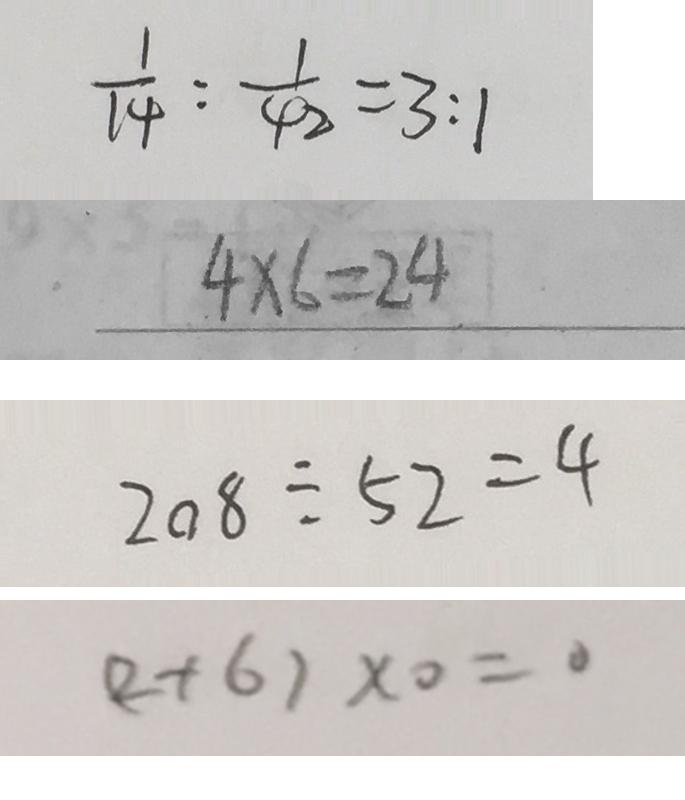Convert formula to latex. <formula><loc_0><loc_0><loc_500><loc_500>\frac { 1 } { 1 4 } : \frac { 1 } { 4 2 } = 3 : 1 
 4 \times 6 = 2 4 
 2 0 8 \div 5 2 = 4 
 ( 2 + 6 ) \times 0 = 0</formula> 